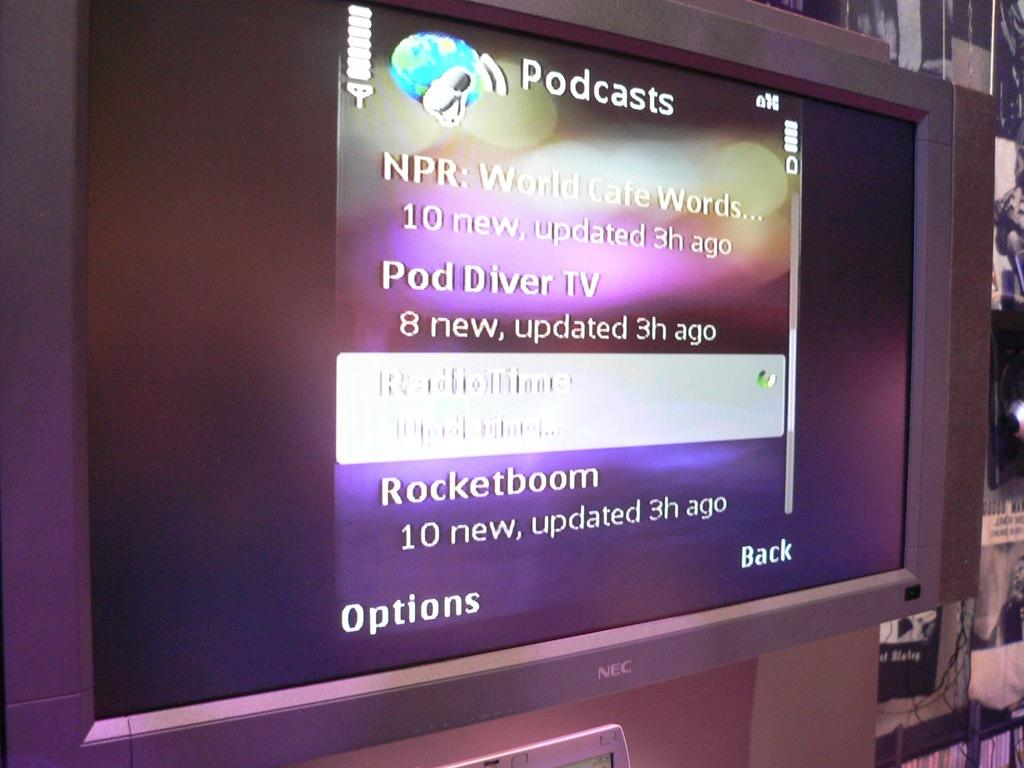<image>
Summarize the visual content of the image. A FLT SCREEN TV HANGING ON A WALL THAT SHOWS A LIST OF PODCAST 